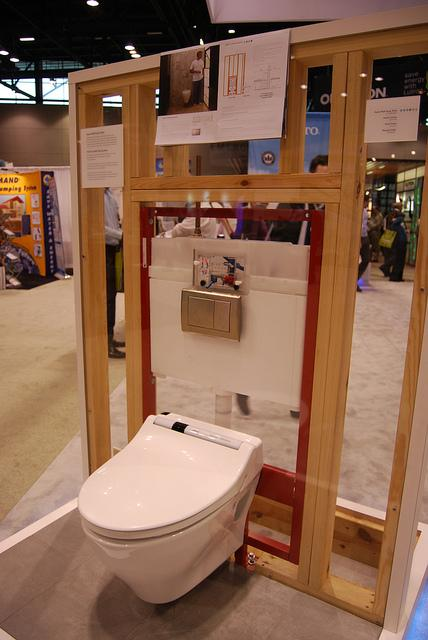Where is this toilet located? store 